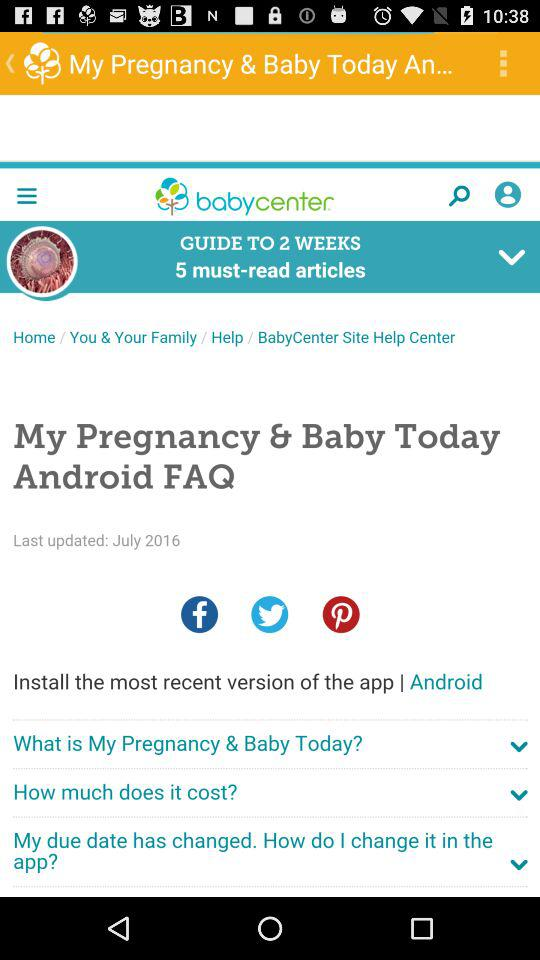How many weeks is the guide for? The guide is for 2 weeks. 